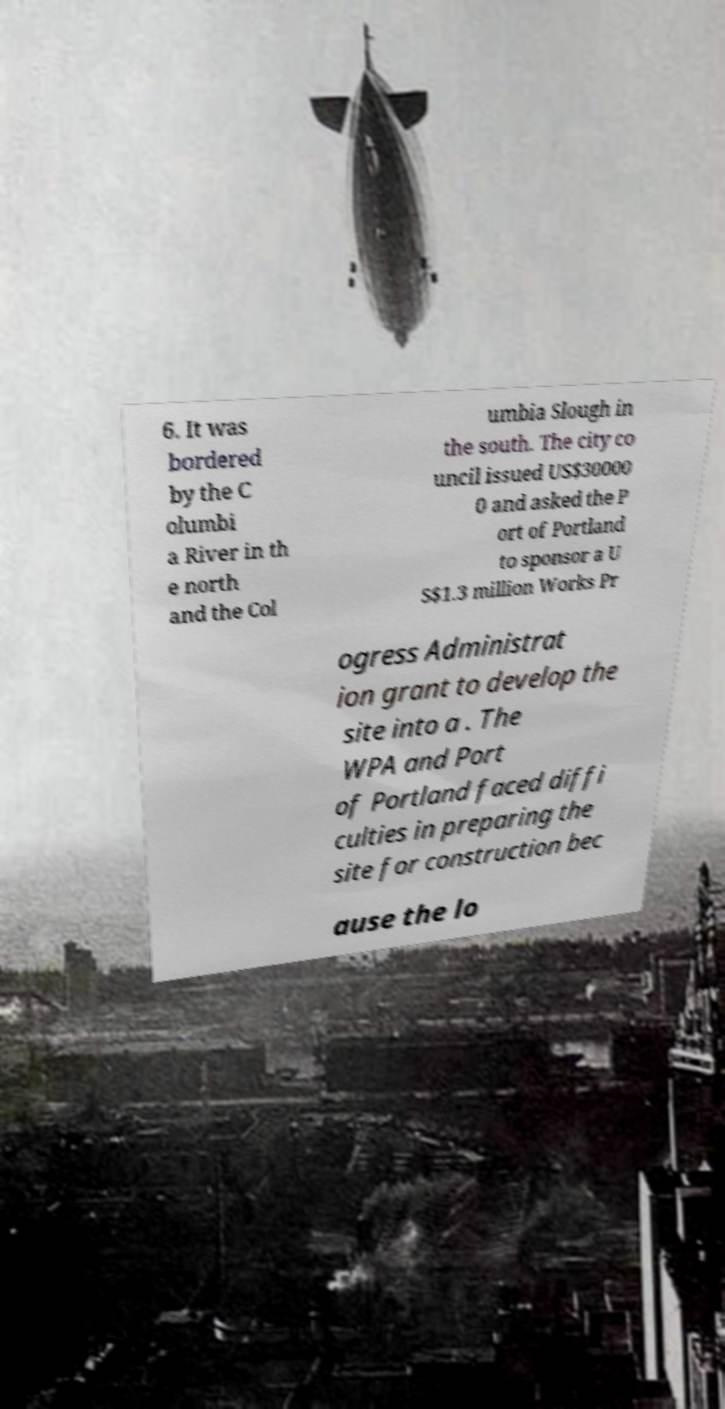What messages or text are displayed in this image? I need them in a readable, typed format. 6. It was bordered by the C olumbi a River in th e north and the Col umbia Slough in the south. The city co uncil issued US$30000 0 and asked the P ort of Portland to sponsor a U S$1.3 million Works Pr ogress Administrat ion grant to develop the site into a . The WPA and Port of Portland faced diffi culties in preparing the site for construction bec ause the lo 